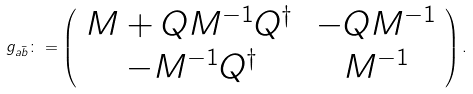Convert formula to latex. <formula><loc_0><loc_0><loc_500><loc_500>g _ { a \bar { b } } \colon = \left ( \begin{array} { c c } M + Q M ^ { - 1 } Q ^ { \dag } \, & - Q M ^ { - 1 } \\ - M ^ { - 1 } Q ^ { \dag } & M ^ { - 1 } \end{array} \right ) .</formula> 